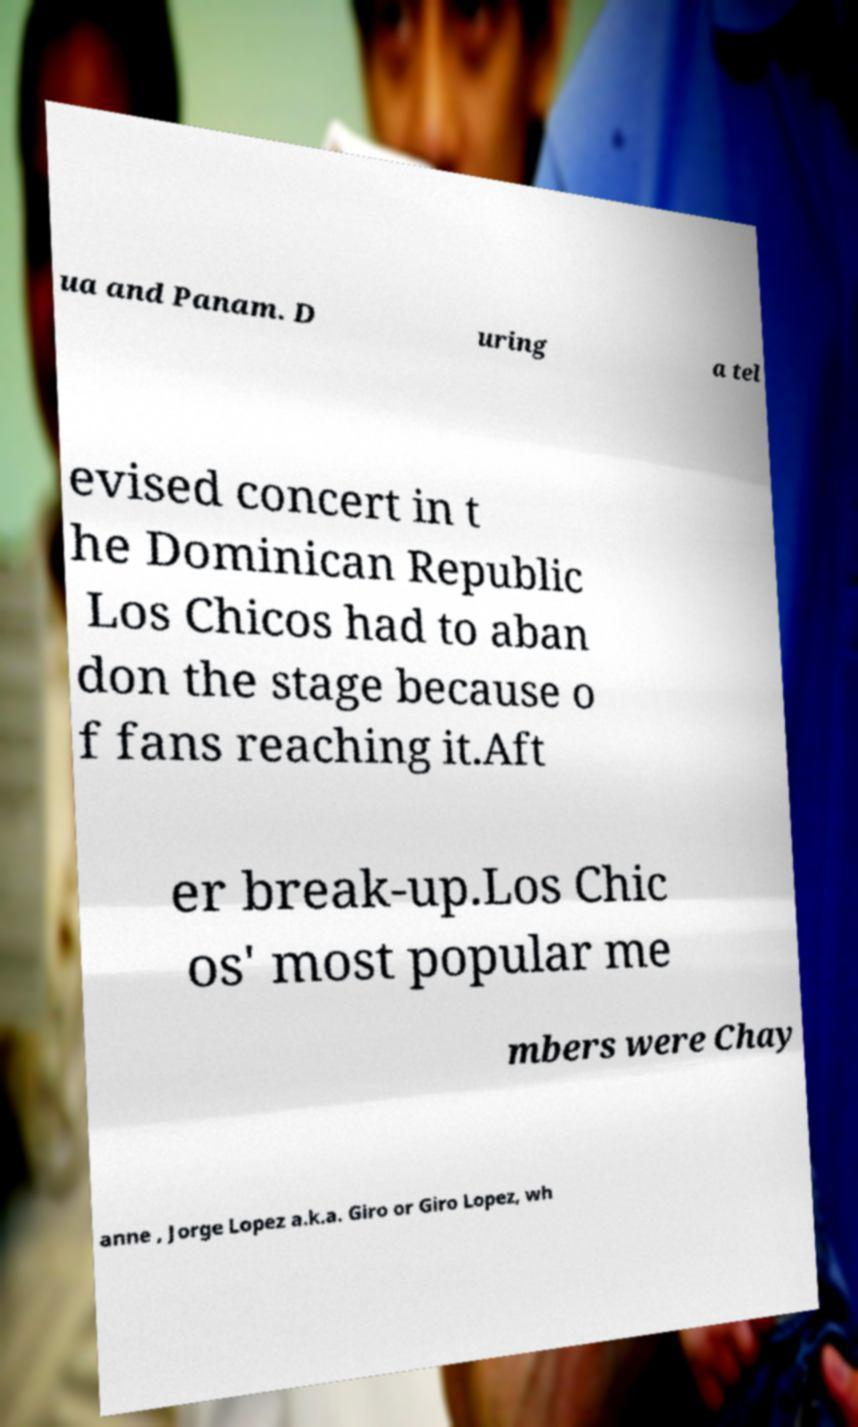There's text embedded in this image that I need extracted. Can you transcribe it verbatim? ua and Panam. D uring a tel evised concert in t he Dominican Republic Los Chicos had to aban don the stage because o f fans reaching it.Aft er break-up.Los Chic os' most popular me mbers were Chay anne , Jorge Lopez a.k.a. Giro or Giro Lopez, wh 